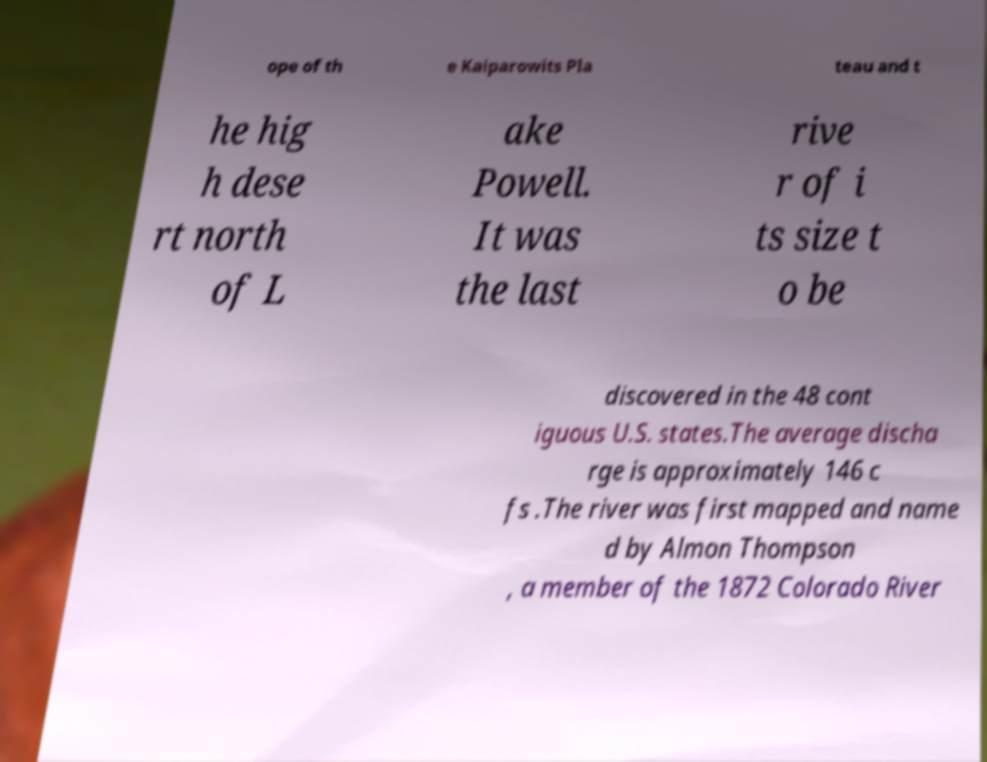Could you assist in decoding the text presented in this image and type it out clearly? ope of th e Kaiparowits Pla teau and t he hig h dese rt north of L ake Powell. It was the last rive r of i ts size t o be discovered in the 48 cont iguous U.S. states.The average discha rge is approximately 146 c fs .The river was first mapped and name d by Almon Thompson , a member of the 1872 Colorado River 